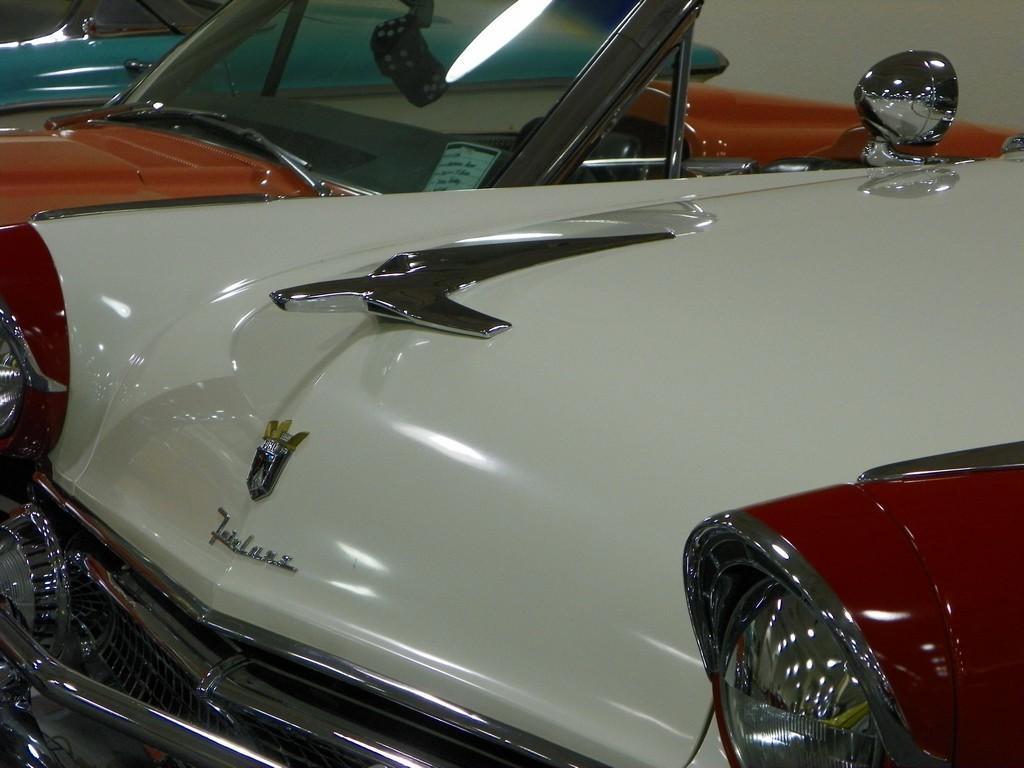Describe this image in one or two sentences. In the image we can see vehicles and here we can see the logo and the headlights of the vehicle. 